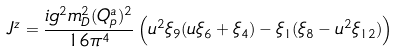<formula> <loc_0><loc_0><loc_500><loc_500>J ^ { z } & = \frac { i g ^ { 2 } { m ^ { 2 } _ { D } } ( { Q _ { p } ^ { a } } ) ^ { 2 } } { 1 6 \pi ^ { 4 } } \left ( u ^ { 2 } \xi _ { 9 } ( u \xi _ { 6 } + \xi _ { 4 } ) - \xi _ { 1 } ( \xi _ { 8 } - u ^ { 2 } \xi _ { 1 2 } ) \right )</formula> 